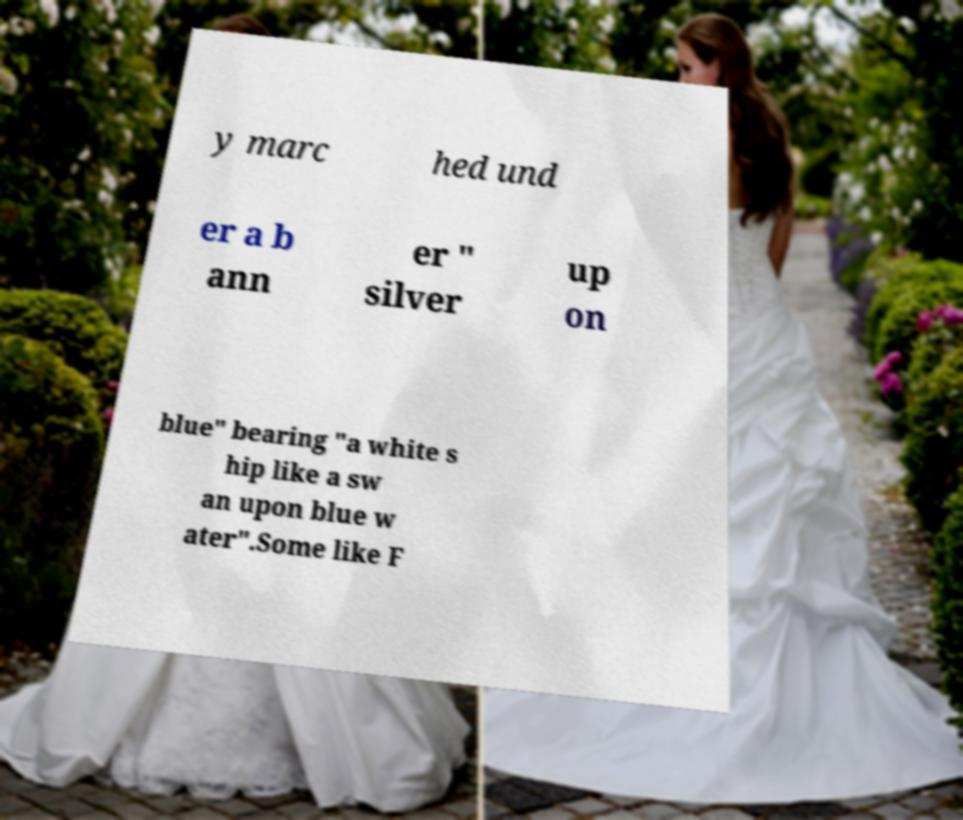Can you accurately transcribe the text from the provided image for me? y marc hed und er a b ann er " silver up on blue" bearing "a white s hip like a sw an upon blue w ater".Some like F 